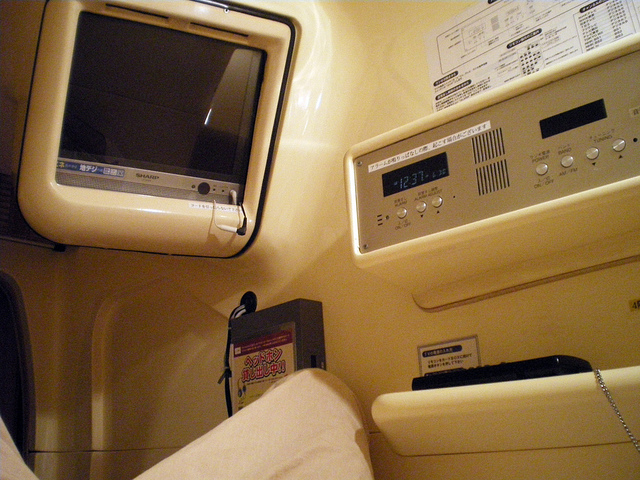Please transcribe the text in this image. 12:37 